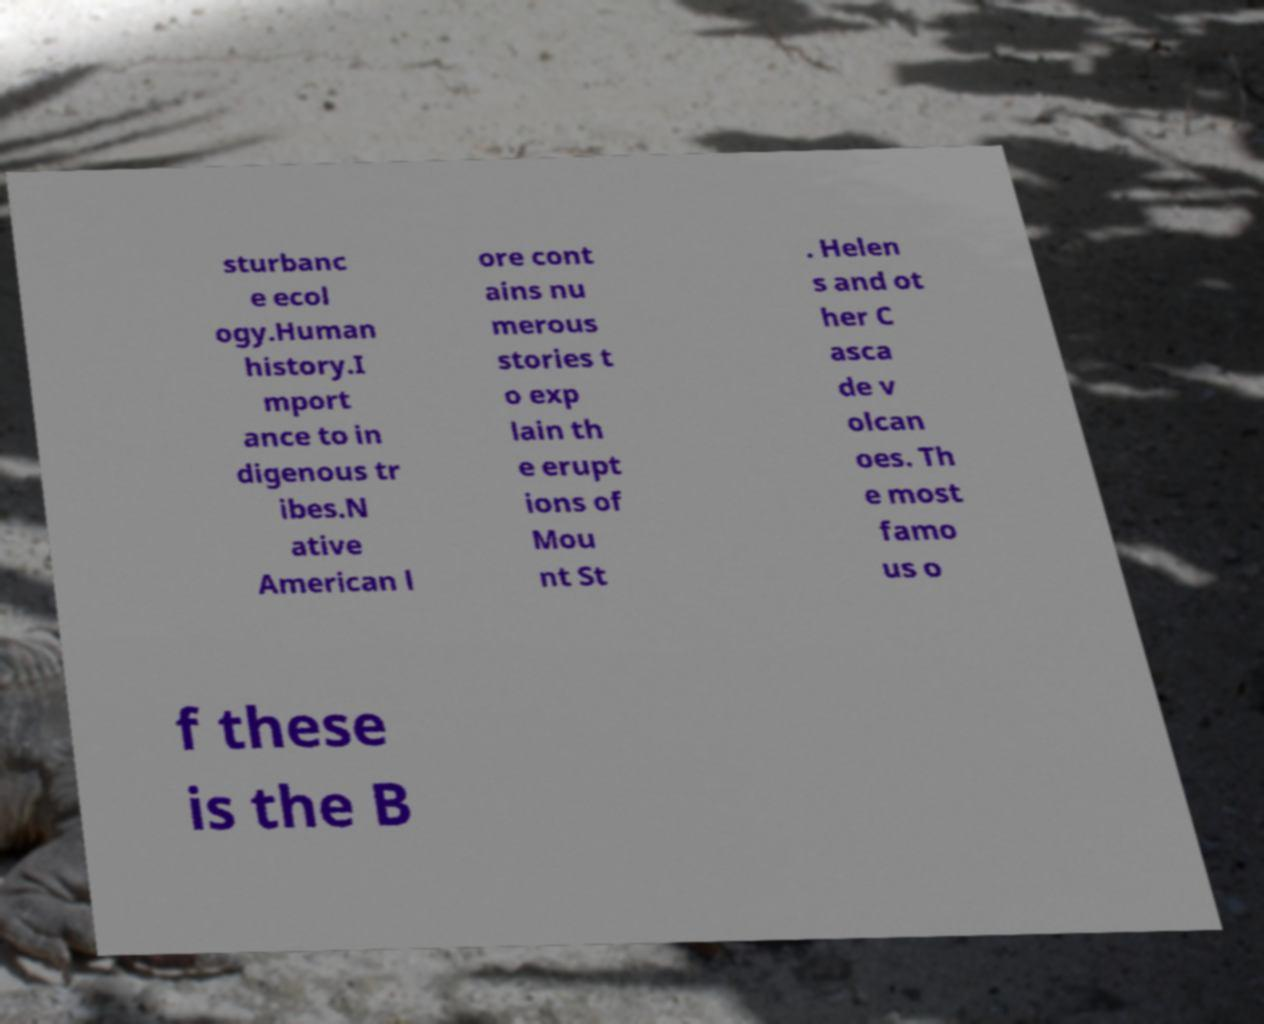I need the written content from this picture converted into text. Can you do that? sturbanc e ecol ogy.Human history.I mport ance to in digenous tr ibes.N ative American l ore cont ains nu merous stories t o exp lain th e erupt ions of Mou nt St . Helen s and ot her C asca de v olcan oes. Th e most famo us o f these is the B 